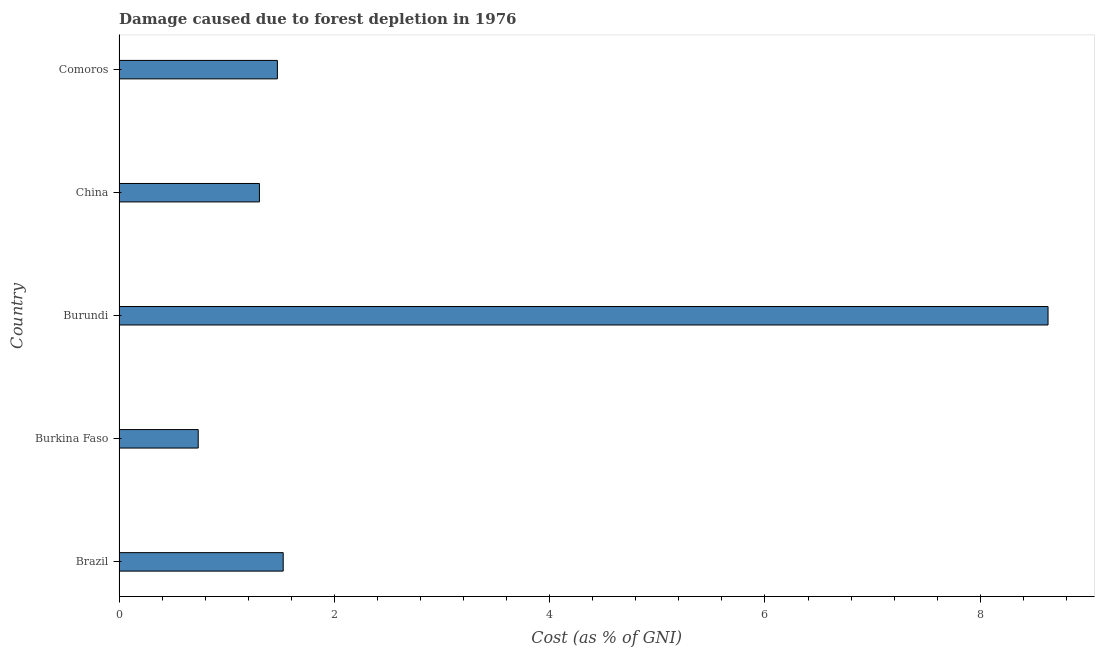What is the title of the graph?
Ensure brevity in your answer.  Damage caused due to forest depletion in 1976. What is the label or title of the X-axis?
Make the answer very short. Cost (as % of GNI). What is the damage caused due to forest depletion in Burkina Faso?
Give a very brief answer. 0.74. Across all countries, what is the maximum damage caused due to forest depletion?
Ensure brevity in your answer.  8.63. Across all countries, what is the minimum damage caused due to forest depletion?
Make the answer very short. 0.74. In which country was the damage caused due to forest depletion maximum?
Your answer should be compact. Burundi. In which country was the damage caused due to forest depletion minimum?
Give a very brief answer. Burkina Faso. What is the sum of the damage caused due to forest depletion?
Your response must be concise. 13.66. What is the difference between the damage caused due to forest depletion in Burkina Faso and China?
Your answer should be very brief. -0.57. What is the average damage caused due to forest depletion per country?
Keep it short and to the point. 2.73. What is the median damage caused due to forest depletion?
Offer a very short reply. 1.47. Is the damage caused due to forest depletion in Burkina Faso less than that in Comoros?
Provide a succinct answer. Yes. What is the difference between the highest and the second highest damage caused due to forest depletion?
Offer a very short reply. 7.11. Is the sum of the damage caused due to forest depletion in Burundi and Comoros greater than the maximum damage caused due to forest depletion across all countries?
Provide a succinct answer. Yes. What is the difference between the highest and the lowest damage caused due to forest depletion?
Ensure brevity in your answer.  7.89. How many bars are there?
Provide a short and direct response. 5. Are all the bars in the graph horizontal?
Offer a very short reply. Yes. How many countries are there in the graph?
Your answer should be very brief. 5. What is the difference between two consecutive major ticks on the X-axis?
Provide a short and direct response. 2. What is the Cost (as % of GNI) in Brazil?
Offer a terse response. 1.52. What is the Cost (as % of GNI) of Burkina Faso?
Keep it short and to the point. 0.74. What is the Cost (as % of GNI) in Burundi?
Keep it short and to the point. 8.63. What is the Cost (as % of GNI) in China?
Your answer should be compact. 1.3. What is the Cost (as % of GNI) in Comoros?
Your answer should be very brief. 1.47. What is the difference between the Cost (as % of GNI) in Brazil and Burkina Faso?
Offer a very short reply. 0.79. What is the difference between the Cost (as % of GNI) in Brazil and Burundi?
Provide a succinct answer. -7.1. What is the difference between the Cost (as % of GNI) in Brazil and China?
Your response must be concise. 0.22. What is the difference between the Cost (as % of GNI) in Brazil and Comoros?
Give a very brief answer. 0.05. What is the difference between the Cost (as % of GNI) in Burkina Faso and Burundi?
Keep it short and to the point. -7.89. What is the difference between the Cost (as % of GNI) in Burkina Faso and China?
Provide a short and direct response. -0.57. What is the difference between the Cost (as % of GNI) in Burkina Faso and Comoros?
Your answer should be compact. -0.74. What is the difference between the Cost (as % of GNI) in Burundi and China?
Provide a succinct answer. 7.33. What is the difference between the Cost (as % of GNI) in Burundi and Comoros?
Provide a short and direct response. 7.16. What is the difference between the Cost (as % of GNI) in China and Comoros?
Provide a short and direct response. -0.17. What is the ratio of the Cost (as % of GNI) in Brazil to that in Burkina Faso?
Provide a succinct answer. 2.07. What is the ratio of the Cost (as % of GNI) in Brazil to that in Burundi?
Provide a short and direct response. 0.18. What is the ratio of the Cost (as % of GNI) in Brazil to that in China?
Offer a very short reply. 1.17. What is the ratio of the Cost (as % of GNI) in Burkina Faso to that in Burundi?
Your response must be concise. 0.09. What is the ratio of the Cost (as % of GNI) in Burkina Faso to that in China?
Offer a very short reply. 0.56. What is the ratio of the Cost (as % of GNI) in Burkina Faso to that in Comoros?
Your answer should be very brief. 0.5. What is the ratio of the Cost (as % of GNI) in Burundi to that in China?
Ensure brevity in your answer.  6.62. What is the ratio of the Cost (as % of GNI) in Burundi to that in Comoros?
Give a very brief answer. 5.87. What is the ratio of the Cost (as % of GNI) in China to that in Comoros?
Ensure brevity in your answer.  0.89. 